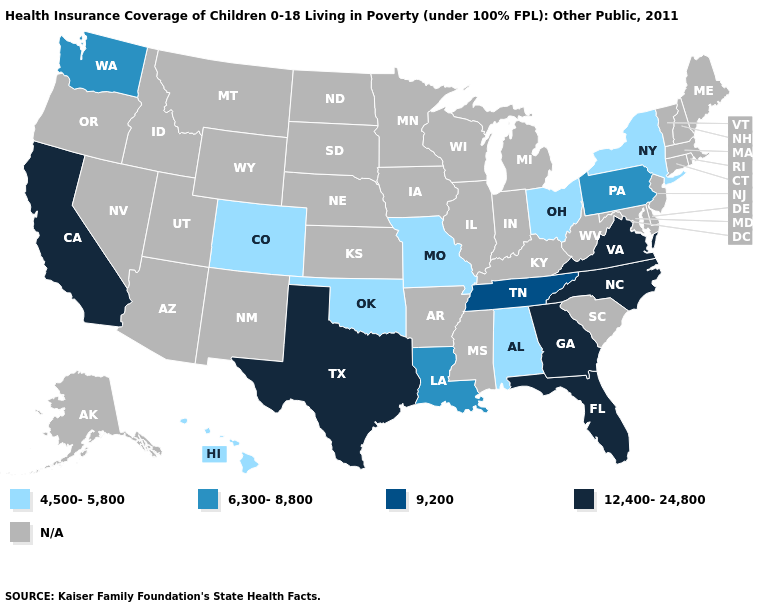Among the states that border Oklahoma , does Texas have the highest value?
Be succinct. Yes. Which states have the lowest value in the South?
Keep it brief. Alabama, Oklahoma. Name the states that have a value in the range 9,200?
Be succinct. Tennessee. Does the map have missing data?
Keep it brief. Yes. How many symbols are there in the legend?
Concise answer only. 5. Does Virginia have the lowest value in the USA?
Quick response, please. No. Does the map have missing data?
Be succinct. Yes. What is the highest value in the USA?
Quick response, please. 12,400-24,800. Does the first symbol in the legend represent the smallest category?
Write a very short answer. Yes. Name the states that have a value in the range 12,400-24,800?
Give a very brief answer. California, Florida, Georgia, North Carolina, Texas, Virginia. What is the value of Massachusetts?
Answer briefly. N/A. Name the states that have a value in the range 4,500-5,800?
Write a very short answer. Alabama, Colorado, Hawaii, Missouri, New York, Ohio, Oklahoma. Name the states that have a value in the range 9,200?
Write a very short answer. Tennessee. What is the value of Utah?
Be succinct. N/A. 